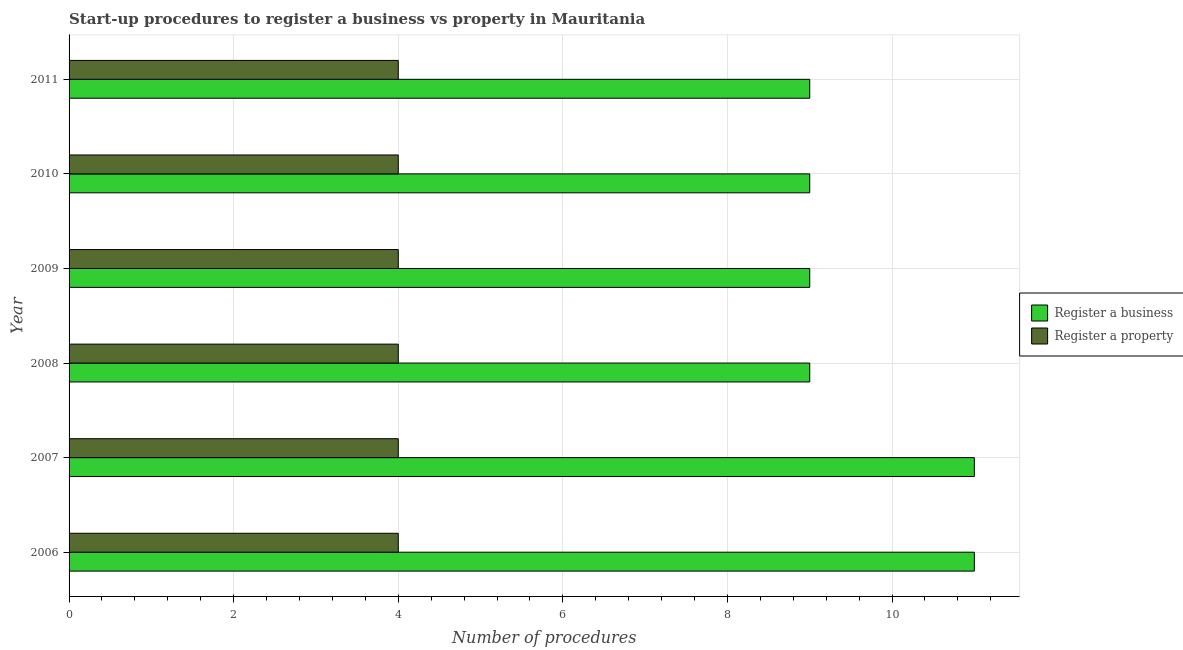Are the number of bars per tick equal to the number of legend labels?
Provide a succinct answer. Yes. How many bars are there on the 4th tick from the top?
Provide a succinct answer. 2. How many bars are there on the 6th tick from the bottom?
Provide a short and direct response. 2. What is the number of procedures to register a business in 2009?
Ensure brevity in your answer.  9. Across all years, what is the maximum number of procedures to register a business?
Make the answer very short. 11. Across all years, what is the minimum number of procedures to register a property?
Your answer should be compact. 4. What is the total number of procedures to register a property in the graph?
Your response must be concise. 24. What is the difference between the number of procedures to register a business in 2006 and that in 2010?
Provide a succinct answer. 2. What is the difference between the number of procedures to register a business in 2009 and the number of procedures to register a property in 2011?
Provide a short and direct response. 5. What is the average number of procedures to register a business per year?
Your response must be concise. 9.67. In the year 2010, what is the difference between the number of procedures to register a property and number of procedures to register a business?
Offer a very short reply. -5. What is the ratio of the number of procedures to register a business in 2006 to that in 2010?
Offer a very short reply. 1.22. Is the number of procedures to register a business in 2007 less than that in 2011?
Your answer should be very brief. No. What is the difference between the highest and the second highest number of procedures to register a property?
Your answer should be very brief. 0. What is the difference between the highest and the lowest number of procedures to register a business?
Provide a succinct answer. 2. In how many years, is the number of procedures to register a business greater than the average number of procedures to register a business taken over all years?
Your response must be concise. 2. What does the 1st bar from the top in 2011 represents?
Offer a terse response. Register a property. What does the 2nd bar from the bottom in 2011 represents?
Provide a succinct answer. Register a property. Are all the bars in the graph horizontal?
Make the answer very short. Yes. Are the values on the major ticks of X-axis written in scientific E-notation?
Ensure brevity in your answer.  No. Does the graph contain any zero values?
Keep it short and to the point. No. Does the graph contain grids?
Provide a succinct answer. Yes. Where does the legend appear in the graph?
Your response must be concise. Center right. How many legend labels are there?
Ensure brevity in your answer.  2. How are the legend labels stacked?
Offer a terse response. Vertical. What is the title of the graph?
Keep it short and to the point. Start-up procedures to register a business vs property in Mauritania. What is the label or title of the X-axis?
Give a very brief answer. Number of procedures. What is the label or title of the Y-axis?
Give a very brief answer. Year. What is the Number of procedures of Register a business in 2006?
Provide a short and direct response. 11. What is the Number of procedures in Register a business in 2007?
Offer a terse response. 11. What is the Number of procedures in Register a business in 2010?
Offer a terse response. 9. Across all years, what is the maximum Number of procedures of Register a business?
Ensure brevity in your answer.  11. Across all years, what is the minimum Number of procedures in Register a business?
Offer a terse response. 9. Across all years, what is the minimum Number of procedures of Register a property?
Ensure brevity in your answer.  4. What is the difference between the Number of procedures of Register a business in 2006 and that in 2007?
Offer a terse response. 0. What is the difference between the Number of procedures in Register a business in 2006 and that in 2008?
Your answer should be very brief. 2. What is the difference between the Number of procedures in Register a business in 2006 and that in 2009?
Make the answer very short. 2. What is the difference between the Number of procedures of Register a property in 2006 and that in 2009?
Offer a terse response. 0. What is the difference between the Number of procedures in Register a business in 2006 and that in 2010?
Make the answer very short. 2. What is the difference between the Number of procedures in Register a business in 2006 and that in 2011?
Offer a very short reply. 2. What is the difference between the Number of procedures in Register a property in 2006 and that in 2011?
Your answer should be compact. 0. What is the difference between the Number of procedures of Register a business in 2007 and that in 2008?
Give a very brief answer. 2. What is the difference between the Number of procedures of Register a property in 2007 and that in 2009?
Provide a succinct answer. 0. What is the difference between the Number of procedures in Register a property in 2007 and that in 2011?
Your response must be concise. 0. What is the difference between the Number of procedures of Register a property in 2008 and that in 2010?
Ensure brevity in your answer.  0. What is the difference between the Number of procedures in Register a business in 2008 and that in 2011?
Your answer should be very brief. 0. What is the difference between the Number of procedures of Register a property in 2008 and that in 2011?
Provide a short and direct response. 0. What is the difference between the Number of procedures of Register a business in 2009 and that in 2010?
Provide a succinct answer. 0. What is the difference between the Number of procedures of Register a business in 2006 and the Number of procedures of Register a property in 2007?
Provide a short and direct response. 7. What is the difference between the Number of procedures in Register a business in 2007 and the Number of procedures in Register a property in 2009?
Offer a terse response. 7. What is the difference between the Number of procedures of Register a business in 2008 and the Number of procedures of Register a property in 2010?
Give a very brief answer. 5. What is the difference between the Number of procedures of Register a business in 2009 and the Number of procedures of Register a property in 2010?
Ensure brevity in your answer.  5. What is the average Number of procedures of Register a business per year?
Give a very brief answer. 9.67. In the year 2006, what is the difference between the Number of procedures of Register a business and Number of procedures of Register a property?
Your answer should be very brief. 7. In the year 2007, what is the difference between the Number of procedures in Register a business and Number of procedures in Register a property?
Make the answer very short. 7. In the year 2010, what is the difference between the Number of procedures of Register a business and Number of procedures of Register a property?
Give a very brief answer. 5. What is the ratio of the Number of procedures in Register a property in 2006 to that in 2007?
Your answer should be compact. 1. What is the ratio of the Number of procedures in Register a business in 2006 to that in 2008?
Your answer should be very brief. 1.22. What is the ratio of the Number of procedures of Register a property in 2006 to that in 2008?
Your answer should be compact. 1. What is the ratio of the Number of procedures of Register a business in 2006 to that in 2009?
Keep it short and to the point. 1.22. What is the ratio of the Number of procedures of Register a property in 2006 to that in 2009?
Give a very brief answer. 1. What is the ratio of the Number of procedures in Register a business in 2006 to that in 2010?
Your answer should be very brief. 1.22. What is the ratio of the Number of procedures of Register a property in 2006 to that in 2010?
Provide a short and direct response. 1. What is the ratio of the Number of procedures in Register a business in 2006 to that in 2011?
Make the answer very short. 1.22. What is the ratio of the Number of procedures in Register a property in 2006 to that in 2011?
Offer a terse response. 1. What is the ratio of the Number of procedures in Register a business in 2007 to that in 2008?
Your answer should be compact. 1.22. What is the ratio of the Number of procedures of Register a property in 2007 to that in 2008?
Your answer should be very brief. 1. What is the ratio of the Number of procedures in Register a business in 2007 to that in 2009?
Provide a short and direct response. 1.22. What is the ratio of the Number of procedures in Register a business in 2007 to that in 2010?
Give a very brief answer. 1.22. What is the ratio of the Number of procedures of Register a business in 2007 to that in 2011?
Your answer should be compact. 1.22. What is the ratio of the Number of procedures of Register a business in 2008 to that in 2009?
Keep it short and to the point. 1. What is the ratio of the Number of procedures in Register a property in 2008 to that in 2009?
Your answer should be very brief. 1. What is the ratio of the Number of procedures of Register a property in 2008 to that in 2010?
Offer a very short reply. 1. What is the ratio of the Number of procedures of Register a property in 2008 to that in 2011?
Your response must be concise. 1. What is the ratio of the Number of procedures in Register a property in 2009 to that in 2010?
Ensure brevity in your answer.  1. What is the ratio of the Number of procedures in Register a business in 2009 to that in 2011?
Keep it short and to the point. 1. What is the ratio of the Number of procedures in Register a property in 2009 to that in 2011?
Offer a terse response. 1. What is the ratio of the Number of procedures of Register a business in 2010 to that in 2011?
Provide a short and direct response. 1. What is the ratio of the Number of procedures of Register a property in 2010 to that in 2011?
Your answer should be compact. 1. What is the difference between the highest and the lowest Number of procedures of Register a property?
Offer a very short reply. 0. 